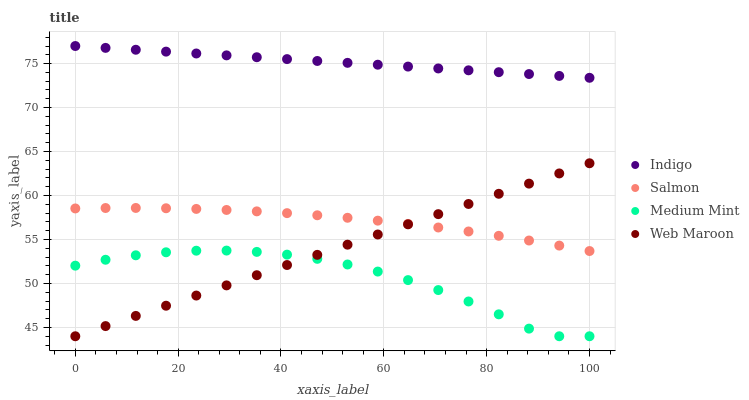Does Medium Mint have the minimum area under the curve?
Answer yes or no. Yes. Does Indigo have the maximum area under the curve?
Answer yes or no. Yes. Does Salmon have the minimum area under the curve?
Answer yes or no. No. Does Salmon have the maximum area under the curve?
Answer yes or no. No. Is Indigo the smoothest?
Answer yes or no. Yes. Is Medium Mint the roughest?
Answer yes or no. Yes. Is Salmon the smoothest?
Answer yes or no. No. Is Salmon the roughest?
Answer yes or no. No. Does Medium Mint have the lowest value?
Answer yes or no. Yes. Does Salmon have the lowest value?
Answer yes or no. No. Does Indigo have the highest value?
Answer yes or no. Yes. Does Salmon have the highest value?
Answer yes or no. No. Is Web Maroon less than Indigo?
Answer yes or no. Yes. Is Indigo greater than Web Maroon?
Answer yes or no. Yes. Does Salmon intersect Web Maroon?
Answer yes or no. Yes. Is Salmon less than Web Maroon?
Answer yes or no. No. Is Salmon greater than Web Maroon?
Answer yes or no. No. Does Web Maroon intersect Indigo?
Answer yes or no. No. 